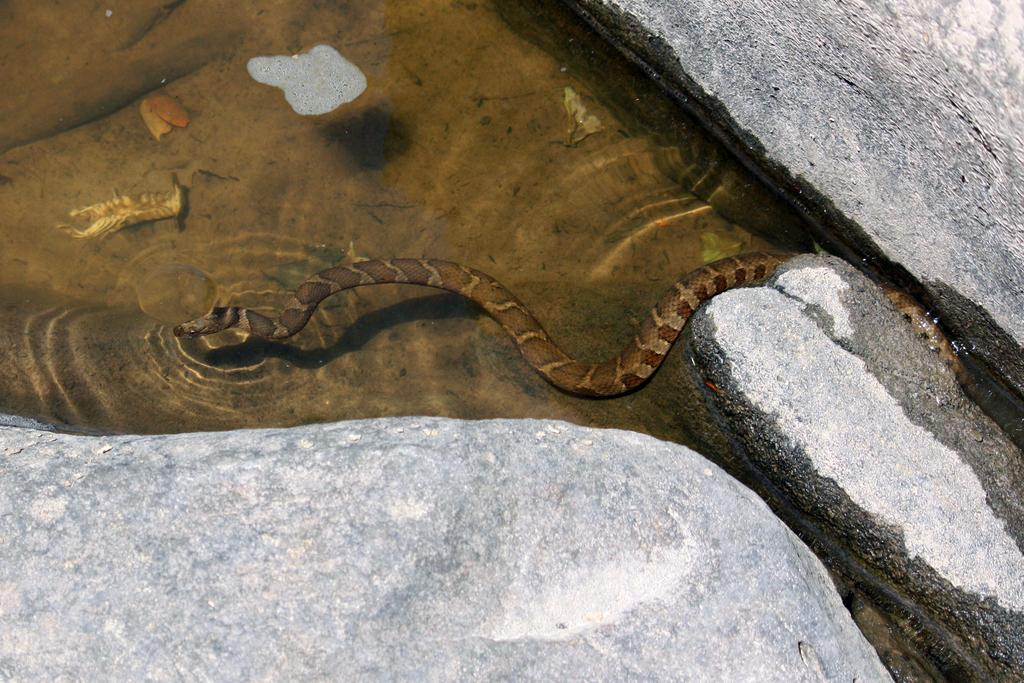What is the main feature of the image? There is a small water pond in the image. What can be seen moving in the water? A brown-colored snake is moving in the water. What is visible at the bottom front side of the image? There are stones visible at the bottom front side of the image. Can you tell me how many grapes are floating in the water pond? There are no grapes present in the image; it features a small water pond with a brown-colored snake moving in the water. Is there a yak visible in the image? There is no yak present in the image. 